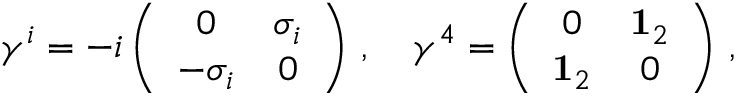Convert formula to latex. <formula><loc_0><loc_0><loc_500><loc_500>\gamma ^ { i } = - i \left ( \begin{array} { c c } { 0 } & { { \sigma _ { i } } } \\ { { - \sigma _ { i } } } & { 0 } \end{array} \right ) \, , \quad \gamma ^ { 4 } = \left ( \begin{array} { c c } { 0 } & { { { 1 } _ { 2 } } } \\ { { { 1 } _ { 2 } } } & { 0 } \end{array} \right ) \, ,</formula> 